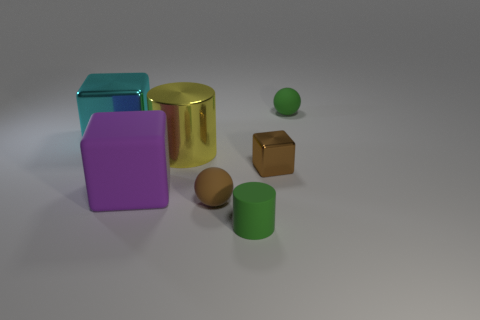Add 1 big rubber objects. How many objects exist? 8 Subtract all cylinders. How many objects are left? 5 Add 6 tiny green matte things. How many tiny green matte things exist? 8 Subtract 0 purple balls. How many objects are left? 7 Subtract all red matte things. Subtract all green cylinders. How many objects are left? 6 Add 3 tiny brown rubber balls. How many tiny brown rubber balls are left? 4 